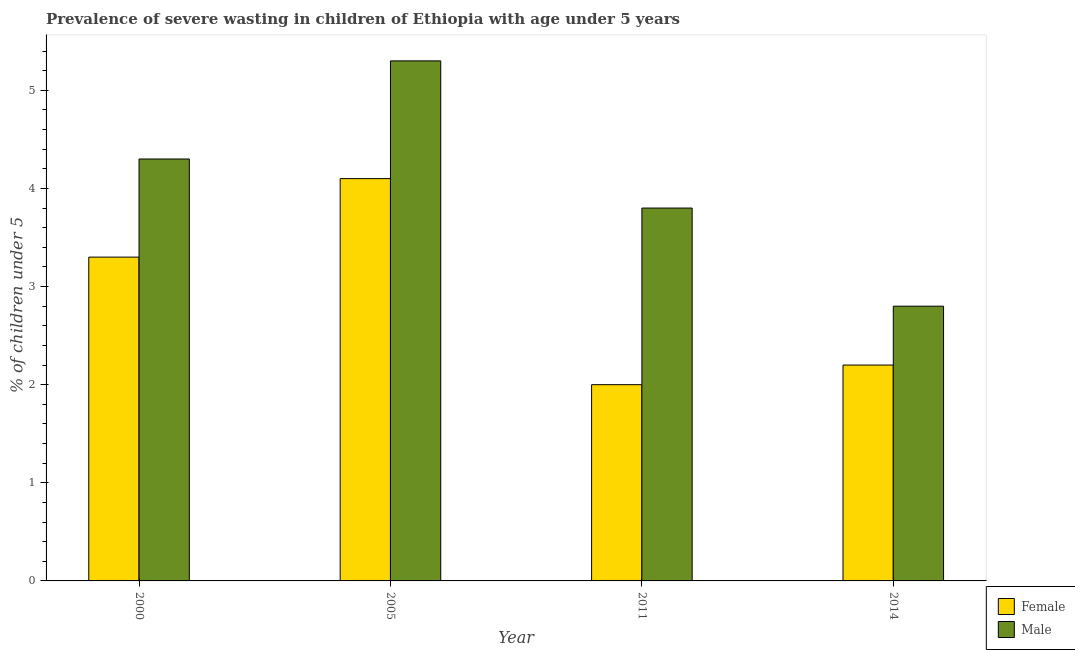How many groups of bars are there?
Provide a short and direct response. 4. Are the number of bars per tick equal to the number of legend labels?
Provide a short and direct response. Yes. Are the number of bars on each tick of the X-axis equal?
Keep it short and to the point. Yes. How many bars are there on the 3rd tick from the left?
Give a very brief answer. 2. What is the label of the 2nd group of bars from the left?
Ensure brevity in your answer.  2005. What is the percentage of undernourished male children in 2011?
Ensure brevity in your answer.  3.8. Across all years, what is the maximum percentage of undernourished male children?
Your response must be concise. 5.3. Across all years, what is the minimum percentage of undernourished male children?
Your answer should be compact. 2.8. In which year was the percentage of undernourished male children maximum?
Your response must be concise. 2005. In which year was the percentage of undernourished female children minimum?
Keep it short and to the point. 2011. What is the total percentage of undernourished female children in the graph?
Offer a very short reply. 11.6. What is the difference between the percentage of undernourished female children in 2011 and the percentage of undernourished male children in 2005?
Keep it short and to the point. -2.1. What is the average percentage of undernourished male children per year?
Give a very brief answer. 4.05. In how many years, is the percentage of undernourished female children greater than 0.8 %?
Ensure brevity in your answer.  4. What is the ratio of the percentage of undernourished male children in 2005 to that in 2014?
Ensure brevity in your answer.  1.89. Is the difference between the percentage of undernourished female children in 2005 and 2014 greater than the difference between the percentage of undernourished male children in 2005 and 2014?
Your response must be concise. No. What is the difference between the highest and the second highest percentage of undernourished male children?
Your answer should be very brief. 1. What is the difference between the highest and the lowest percentage of undernourished female children?
Your answer should be compact. 2.1. In how many years, is the percentage of undernourished male children greater than the average percentage of undernourished male children taken over all years?
Offer a terse response. 2. What does the 2nd bar from the left in 2014 represents?
Your answer should be compact. Male. What does the 1st bar from the right in 2014 represents?
Offer a terse response. Male. How many bars are there?
Provide a succinct answer. 8. How many years are there in the graph?
Provide a succinct answer. 4. What is the difference between two consecutive major ticks on the Y-axis?
Your answer should be very brief. 1. Does the graph contain grids?
Give a very brief answer. No. Where does the legend appear in the graph?
Your response must be concise. Bottom right. How many legend labels are there?
Your answer should be compact. 2. How are the legend labels stacked?
Your answer should be very brief. Vertical. What is the title of the graph?
Provide a succinct answer. Prevalence of severe wasting in children of Ethiopia with age under 5 years. Does "All education staff compensation" appear as one of the legend labels in the graph?
Your answer should be compact. No. What is the label or title of the Y-axis?
Your answer should be compact.  % of children under 5. What is the  % of children under 5 of Female in 2000?
Your answer should be very brief. 3.3. What is the  % of children under 5 of Male in 2000?
Ensure brevity in your answer.  4.3. What is the  % of children under 5 in Female in 2005?
Provide a short and direct response. 4.1. What is the  % of children under 5 in Male in 2005?
Your answer should be very brief. 5.3. What is the  % of children under 5 of Female in 2011?
Provide a succinct answer. 2. What is the  % of children under 5 of Male in 2011?
Your answer should be very brief. 3.8. What is the  % of children under 5 of Female in 2014?
Keep it short and to the point. 2.2. What is the  % of children under 5 of Male in 2014?
Make the answer very short. 2.8. Across all years, what is the maximum  % of children under 5 of Female?
Give a very brief answer. 4.1. Across all years, what is the maximum  % of children under 5 of Male?
Make the answer very short. 5.3. Across all years, what is the minimum  % of children under 5 in Female?
Ensure brevity in your answer.  2. Across all years, what is the minimum  % of children under 5 of Male?
Offer a very short reply. 2.8. What is the total  % of children under 5 in Female in the graph?
Your answer should be very brief. 11.6. What is the difference between the  % of children under 5 in Male in 2000 and that in 2005?
Offer a very short reply. -1. What is the difference between the  % of children under 5 in Female in 2000 and that in 2014?
Keep it short and to the point. 1.1. What is the difference between the  % of children under 5 of Male in 2000 and that in 2014?
Provide a short and direct response. 1.5. What is the difference between the  % of children under 5 in Female in 2005 and that in 2011?
Provide a succinct answer. 2.1. What is the difference between the  % of children under 5 of Male in 2005 and that in 2011?
Your answer should be compact. 1.5. What is the difference between the  % of children under 5 of Female in 2005 and that in 2014?
Your answer should be very brief. 1.9. What is the difference between the  % of children under 5 in Male in 2005 and that in 2014?
Make the answer very short. 2.5. What is the difference between the  % of children under 5 of Male in 2011 and that in 2014?
Give a very brief answer. 1. What is the difference between the  % of children under 5 of Female in 2000 and the  % of children under 5 of Male in 2011?
Your response must be concise. -0.5. What is the difference between the  % of children under 5 in Female in 2000 and the  % of children under 5 in Male in 2014?
Offer a terse response. 0.5. What is the difference between the  % of children under 5 in Female in 2005 and the  % of children under 5 in Male in 2011?
Your answer should be compact. 0.3. What is the difference between the  % of children under 5 in Female in 2005 and the  % of children under 5 in Male in 2014?
Ensure brevity in your answer.  1.3. What is the difference between the  % of children under 5 in Female in 2011 and the  % of children under 5 in Male in 2014?
Keep it short and to the point. -0.8. What is the average  % of children under 5 in Female per year?
Your response must be concise. 2.9. What is the average  % of children under 5 in Male per year?
Ensure brevity in your answer.  4.05. What is the ratio of the  % of children under 5 in Female in 2000 to that in 2005?
Your answer should be very brief. 0.8. What is the ratio of the  % of children under 5 in Male in 2000 to that in 2005?
Give a very brief answer. 0.81. What is the ratio of the  % of children under 5 in Female in 2000 to that in 2011?
Give a very brief answer. 1.65. What is the ratio of the  % of children under 5 in Male in 2000 to that in 2011?
Provide a succinct answer. 1.13. What is the ratio of the  % of children under 5 in Female in 2000 to that in 2014?
Give a very brief answer. 1.5. What is the ratio of the  % of children under 5 in Male in 2000 to that in 2014?
Keep it short and to the point. 1.54. What is the ratio of the  % of children under 5 in Female in 2005 to that in 2011?
Offer a terse response. 2.05. What is the ratio of the  % of children under 5 of Male in 2005 to that in 2011?
Your response must be concise. 1.39. What is the ratio of the  % of children under 5 of Female in 2005 to that in 2014?
Keep it short and to the point. 1.86. What is the ratio of the  % of children under 5 of Male in 2005 to that in 2014?
Offer a very short reply. 1.89. What is the ratio of the  % of children under 5 of Male in 2011 to that in 2014?
Provide a succinct answer. 1.36. What is the difference between the highest and the second highest  % of children under 5 in Male?
Your answer should be very brief. 1. What is the difference between the highest and the lowest  % of children under 5 of Female?
Make the answer very short. 2.1. What is the difference between the highest and the lowest  % of children under 5 in Male?
Offer a very short reply. 2.5. 